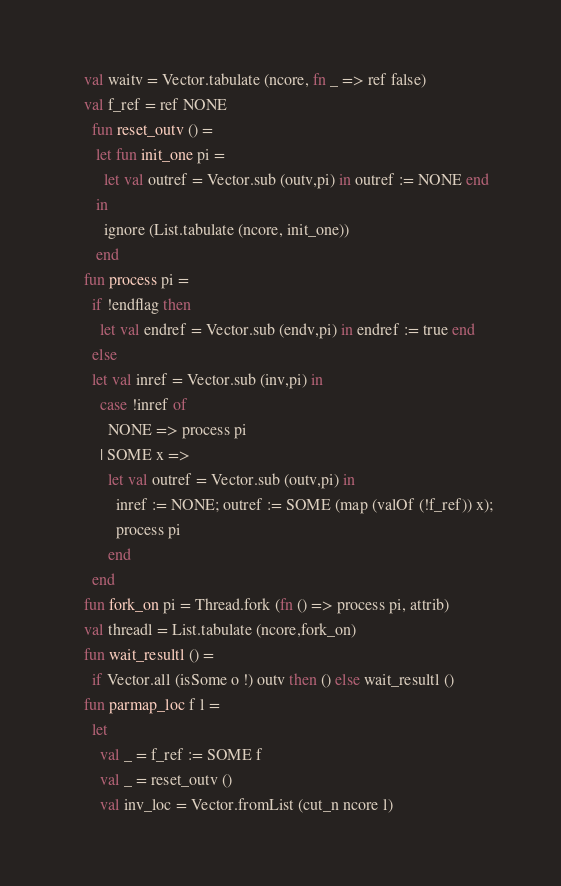Convert code to text. <code><loc_0><loc_0><loc_500><loc_500><_SML_>    val waitv = Vector.tabulate (ncore, fn _ => ref false)
    val f_ref = ref NONE
      fun reset_outv () =
       let fun init_one pi =
         let val outref = Vector.sub (outv,pi) in outref := NONE end
       in
         ignore (List.tabulate (ncore, init_one))
       end
    fun process pi =
      if !endflag then
        let val endref = Vector.sub (endv,pi) in endref := true end
      else
      let val inref = Vector.sub (inv,pi) in
        case !inref of
          NONE => process pi
        | SOME x =>
          let val outref = Vector.sub (outv,pi) in
            inref := NONE; outref := SOME (map (valOf (!f_ref)) x);
            process pi
          end
      end
    fun fork_on pi = Thread.fork (fn () => process pi, attrib)
    val threadl = List.tabulate (ncore,fork_on)
    fun wait_resultl () =
      if Vector.all (isSome o !) outv then () else wait_resultl ()
    fun parmap_loc f l =
      let
        val _ = f_ref := SOME f
        val _ = reset_outv ()
        val inv_loc = Vector.fromList (cut_n ncore l)</code> 